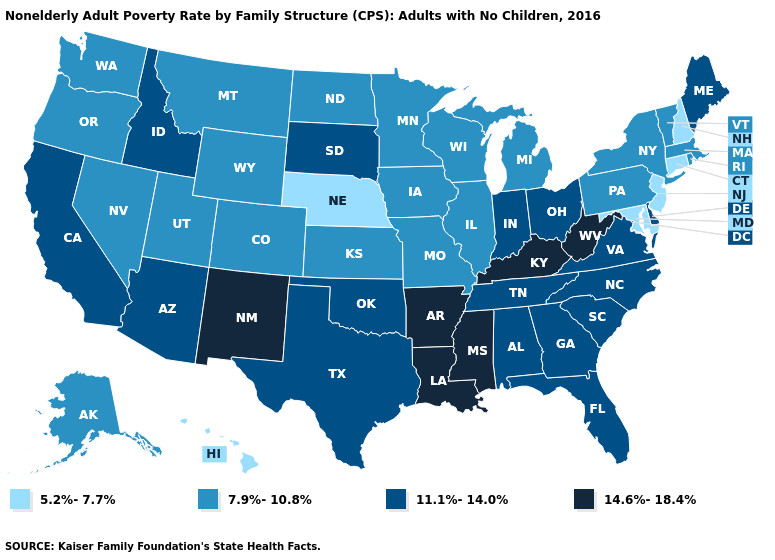Does Louisiana have the highest value in the USA?
Give a very brief answer. Yes. Among the states that border Oklahoma , does Arkansas have the highest value?
Short answer required. Yes. Which states have the lowest value in the USA?
Give a very brief answer. Connecticut, Hawaii, Maryland, Nebraska, New Hampshire, New Jersey. Does Ohio have a lower value than Louisiana?
Answer briefly. Yes. Does Indiana have the highest value in the MidWest?
Concise answer only. Yes. Among the states that border New Hampshire , which have the highest value?
Answer briefly. Maine. Which states have the lowest value in the West?
Write a very short answer. Hawaii. Name the states that have a value in the range 7.9%-10.8%?
Give a very brief answer. Alaska, Colorado, Illinois, Iowa, Kansas, Massachusetts, Michigan, Minnesota, Missouri, Montana, Nevada, New York, North Dakota, Oregon, Pennsylvania, Rhode Island, Utah, Vermont, Washington, Wisconsin, Wyoming. Does Indiana have the highest value in the MidWest?
Write a very short answer. Yes. Which states hav the highest value in the MidWest?
Give a very brief answer. Indiana, Ohio, South Dakota. Name the states that have a value in the range 11.1%-14.0%?
Write a very short answer. Alabama, Arizona, California, Delaware, Florida, Georgia, Idaho, Indiana, Maine, North Carolina, Ohio, Oklahoma, South Carolina, South Dakota, Tennessee, Texas, Virginia. How many symbols are there in the legend?
Keep it brief. 4. Does Ohio have a higher value than Washington?
Short answer required. Yes. What is the highest value in the West ?
Be succinct. 14.6%-18.4%. What is the value of West Virginia?
Short answer required. 14.6%-18.4%. 